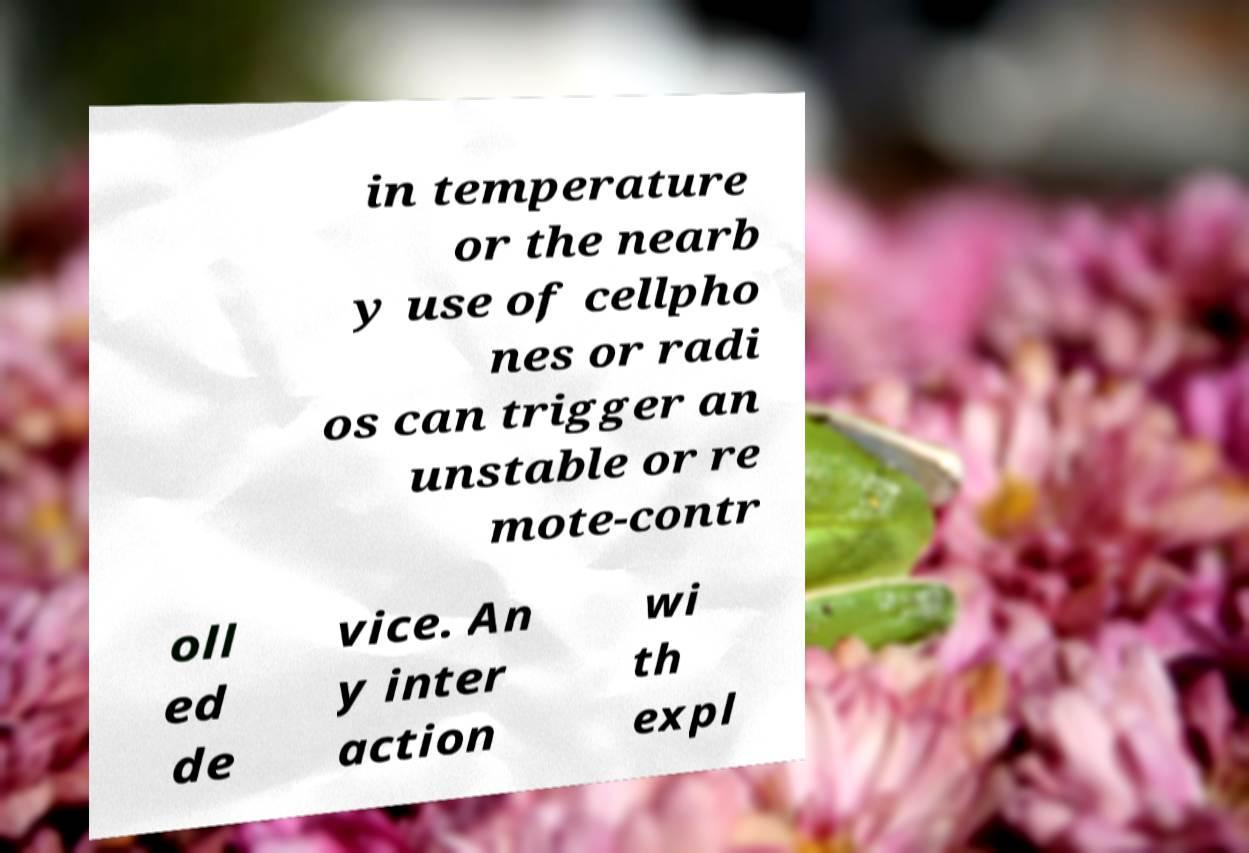Could you extract and type out the text from this image? in temperature or the nearb y use of cellpho nes or radi os can trigger an unstable or re mote-contr oll ed de vice. An y inter action wi th expl 